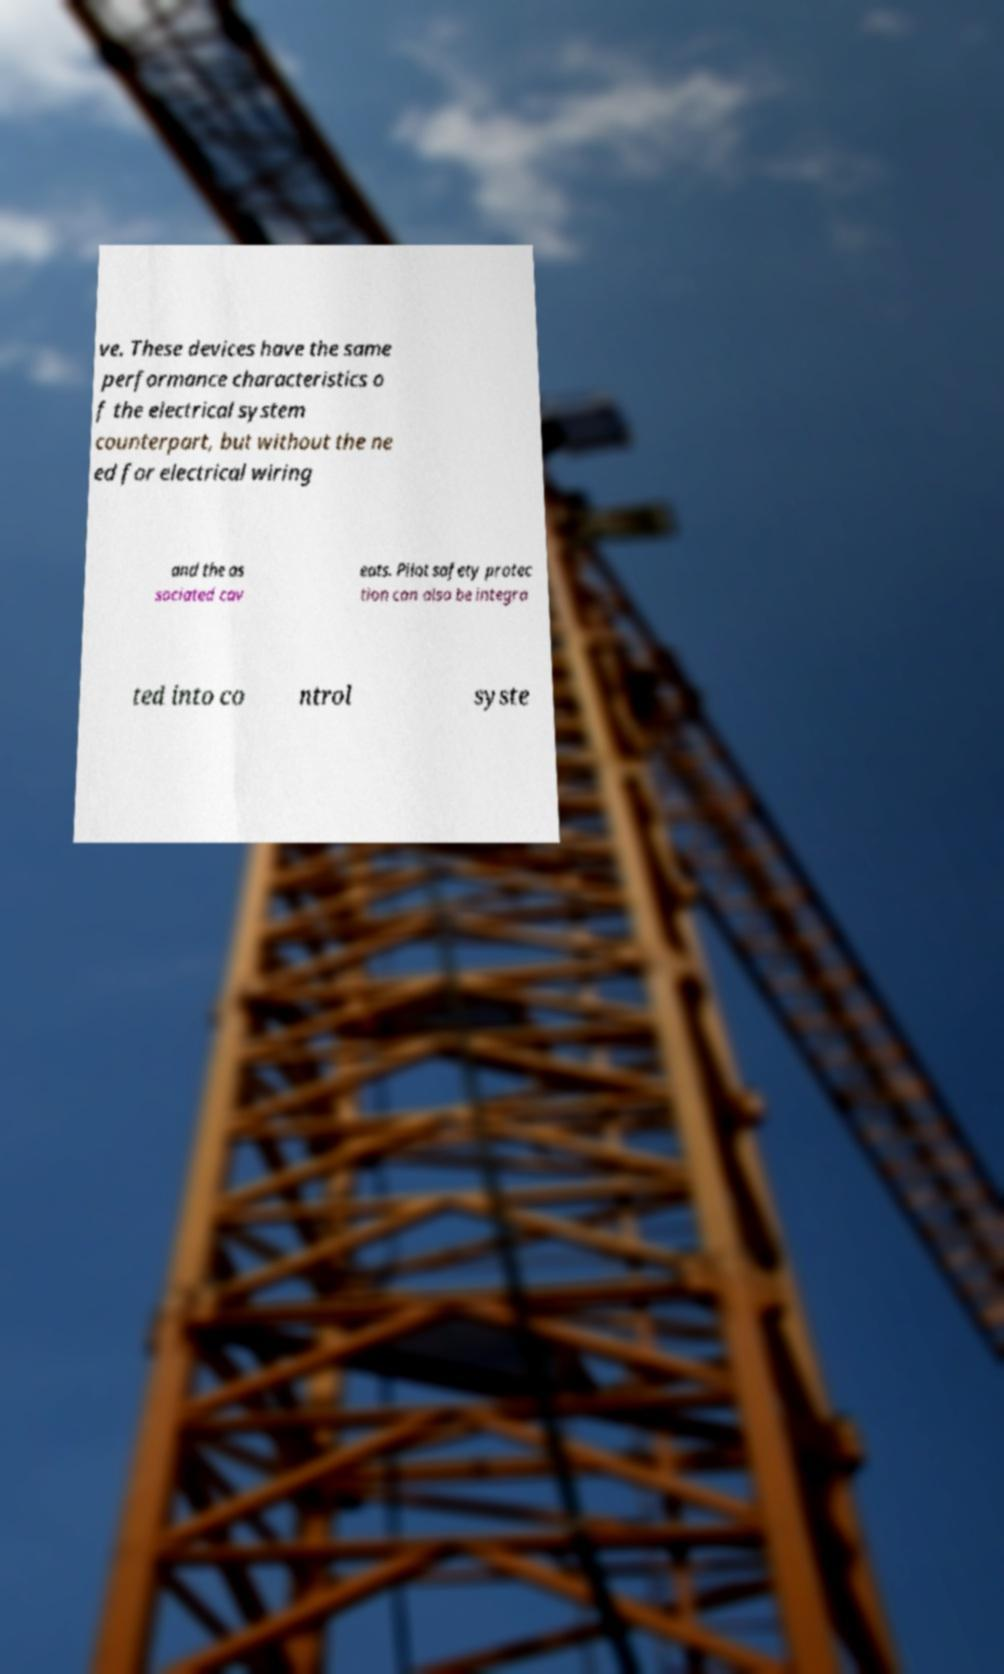Can you accurately transcribe the text from the provided image for me? ve. These devices have the same performance characteristics o f the electrical system counterpart, but without the ne ed for electrical wiring and the as sociated cav eats. Pilot safety protec tion can also be integra ted into co ntrol syste 